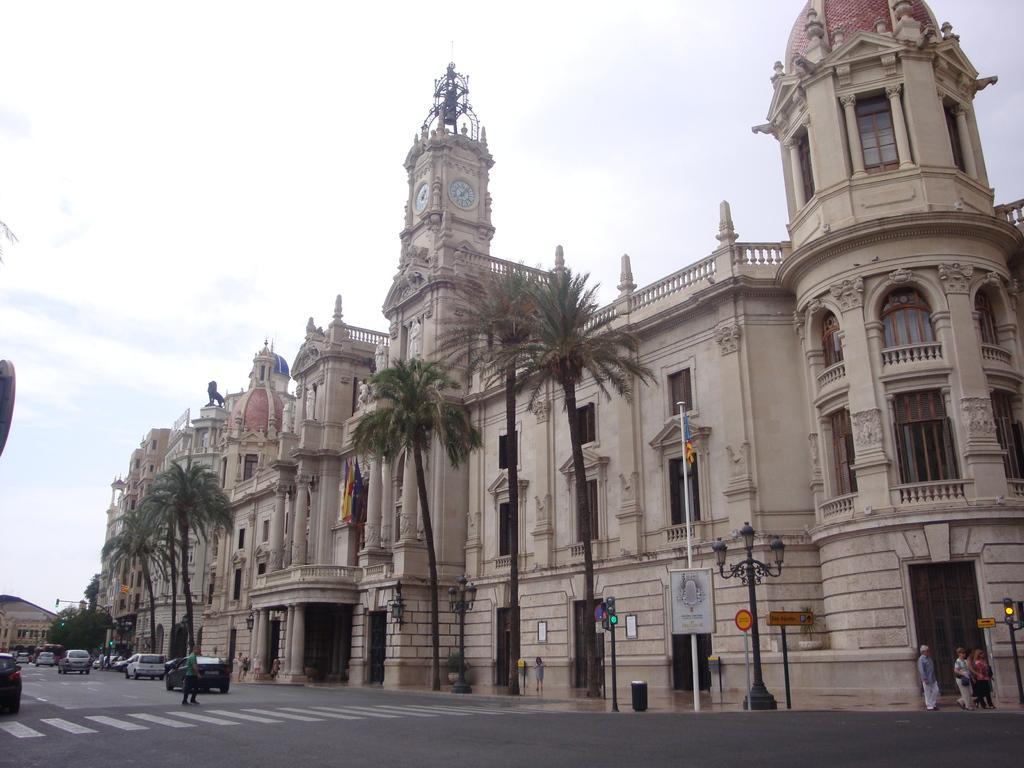Could you give a brief overview of what you see in this image? In this image we can see buildings, vehicles on the road, there are light poles, traffic lights, boards with text on them, there is a dustbin, there are a few people, also we can see trees, and the sky. 